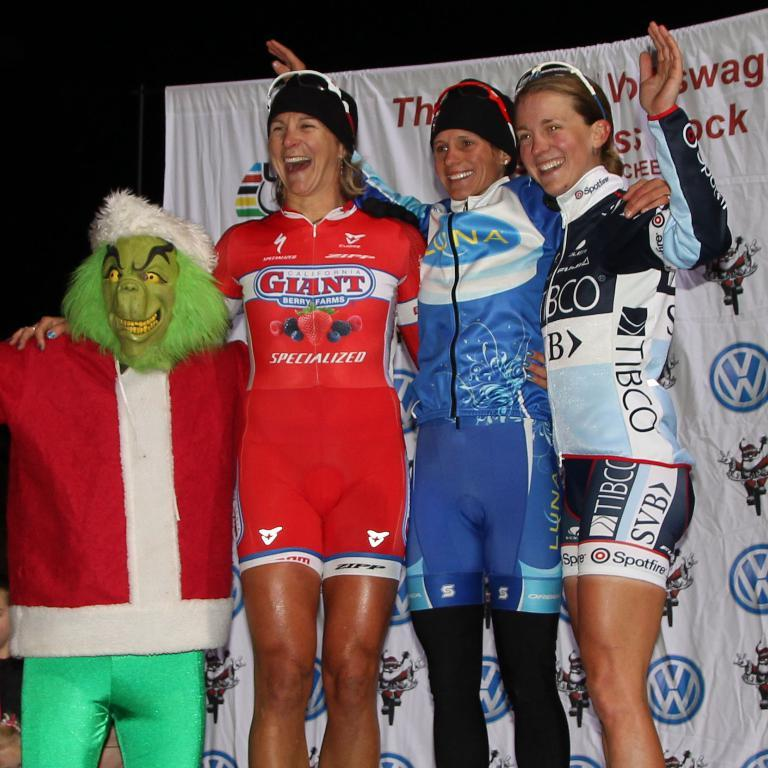<image>
Describe the image concisely. short person dressed as a santa grinch next to woman in red giant berries outfit, woman in blue luna bar outfit, and another in black and white tibco outfit 